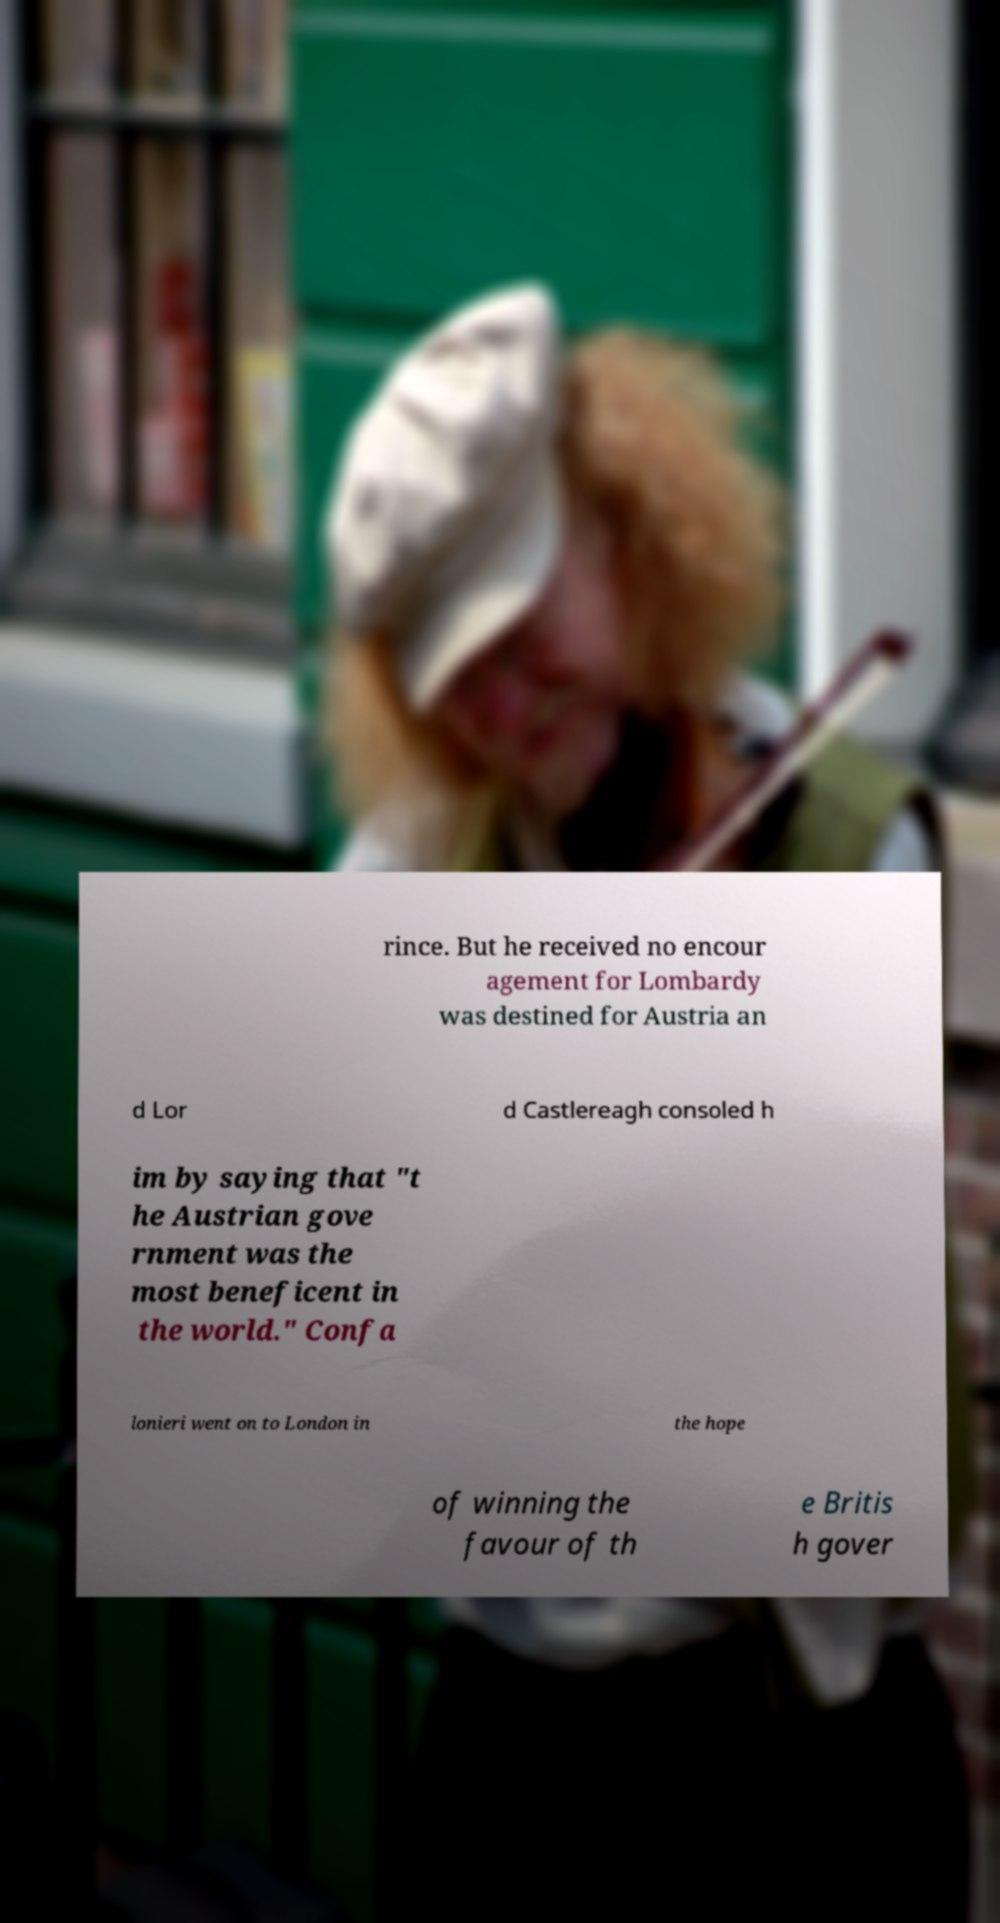I need the written content from this picture converted into text. Can you do that? rince. But he received no encour agement for Lombardy was destined for Austria an d Lor d Castlereagh consoled h im by saying that "t he Austrian gove rnment was the most beneficent in the world." Confa lonieri went on to London in the hope of winning the favour of th e Britis h gover 